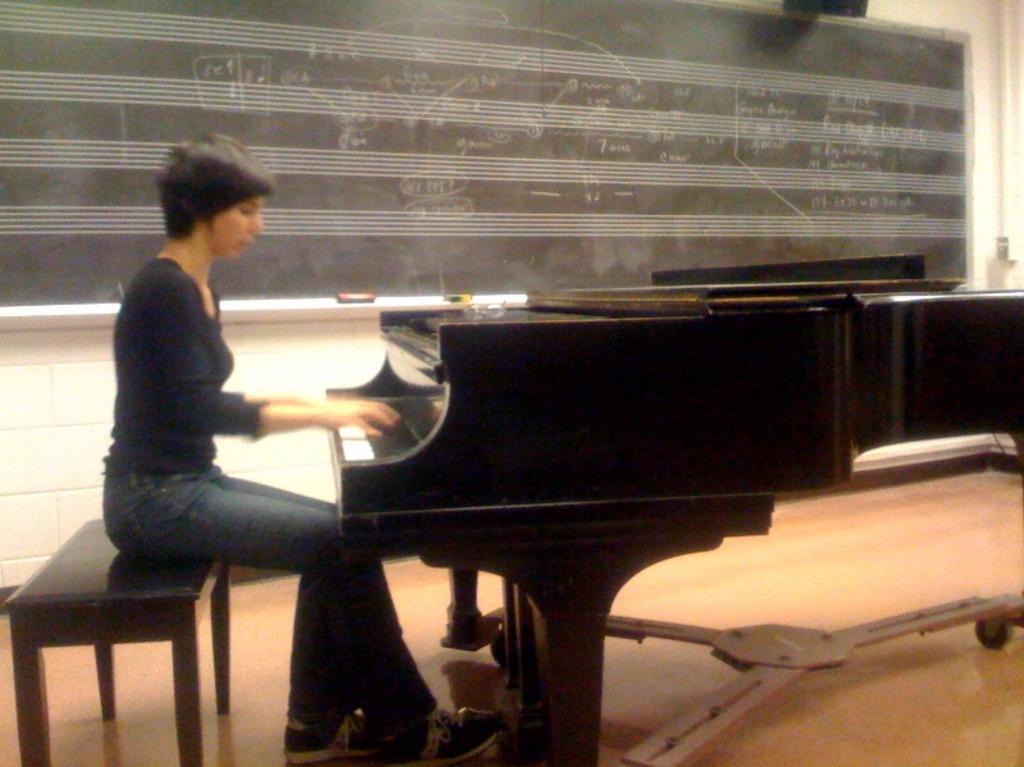Please provide a concise description of this image. In this picture woman sitting on a bench. At the left side there is a piano table. In the background there is a black colour board and a wall. 